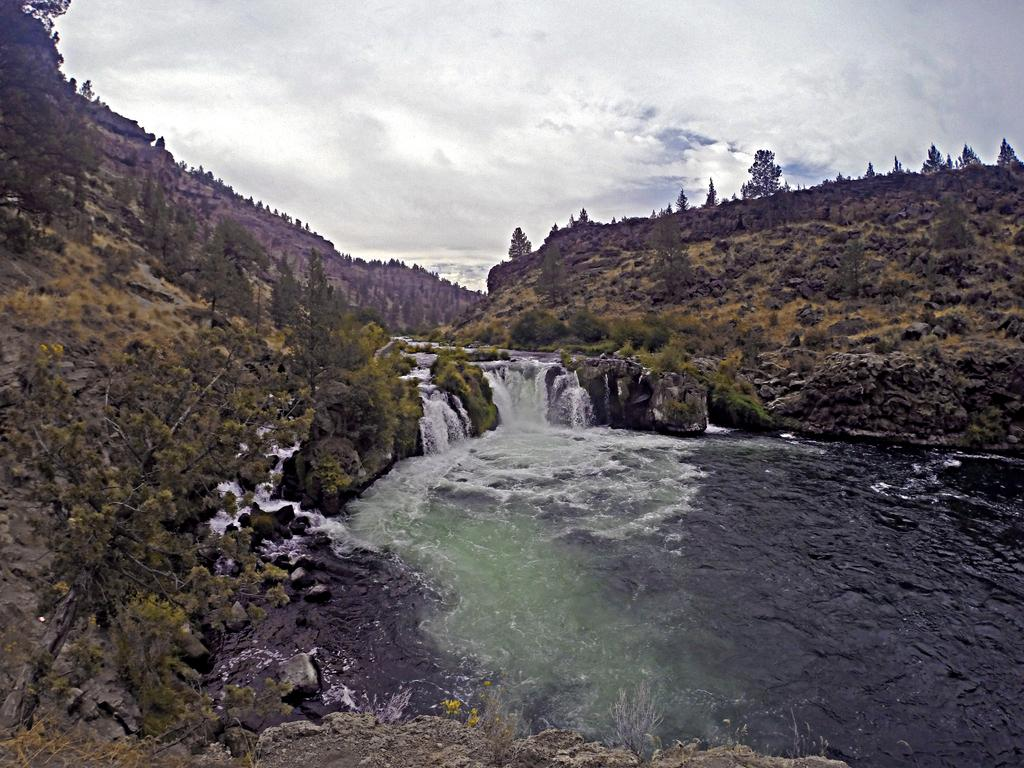What type of vegetation is on the left side of the image? There are trees on the left side of the image. What can be seen at the bottom of the image? There is water flow visible at the bottom of the image. What is visible in the background of the image? Trees and hills are present in the background of the image. What is visible at the top of the image? The sky is visible at the top of the image. Where is the tin located in the image? There is no tin present in the image. What type of nest can be seen in the aftermath of the storm in the image? There is no storm or nest present in the image. 